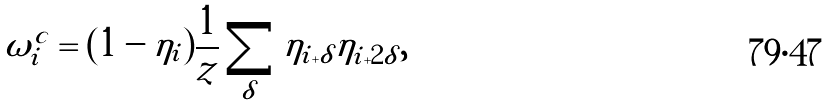Convert formula to latex. <formula><loc_0><loc_0><loc_500><loc_500>\omega _ { i } ^ { c } = ( 1 - \eta _ { i } ) \frac { 1 } { z } \sum _ { \delta } \eta _ { i + \delta } \eta _ { i + 2 \delta } ,</formula> 